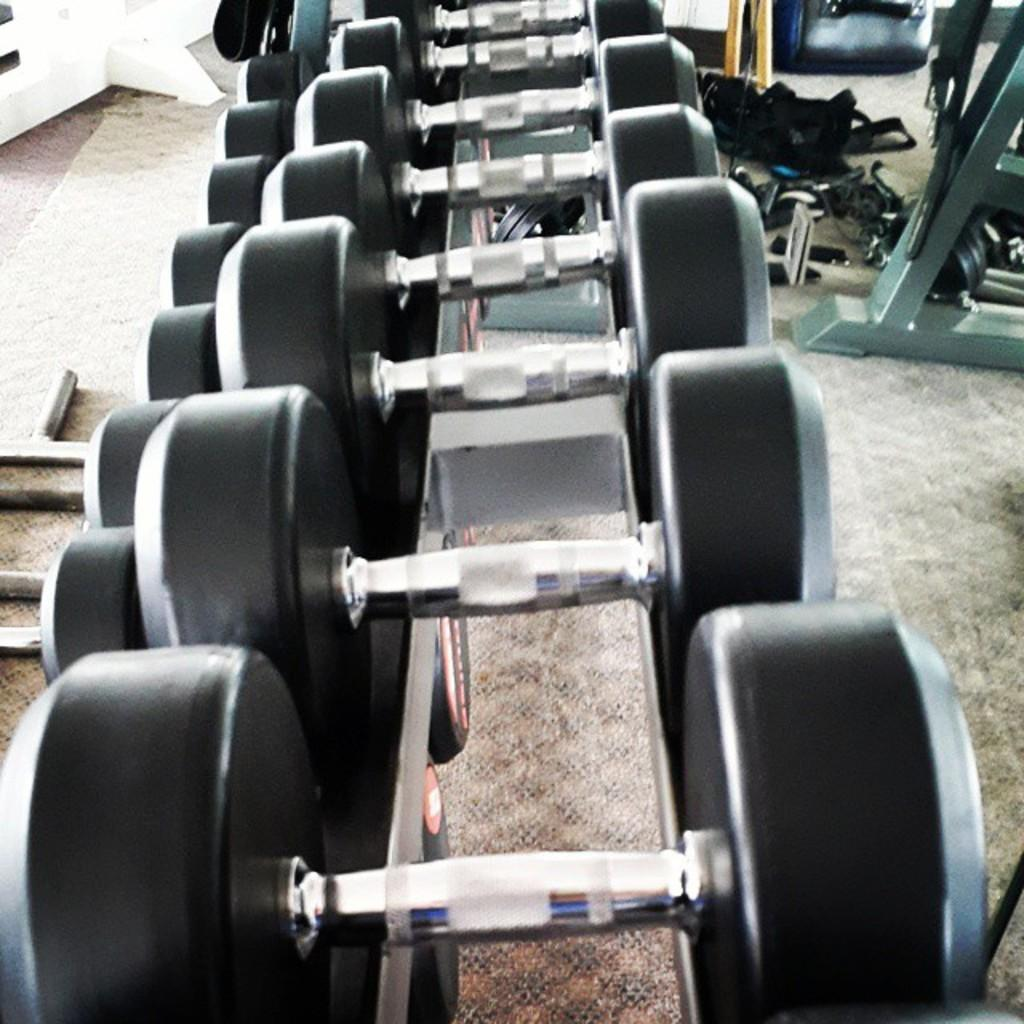What type of location is depicted in the image? The image shows the inside of a gym. What equipment can be seen on a stand in the image? There are dumbbells on a stand in the image. What other gym equipment is visible on the floor? There are other gym instruments on the floor in the image. What type of surface is on the floor of the gym? The floor has a floor mat in the image. Can you see any screws or wrenches on the gym equipment in the image? There is no mention of screws or wrenches in the image; the focus is on the gym equipment itself, such as dumbbells and other instruments. 